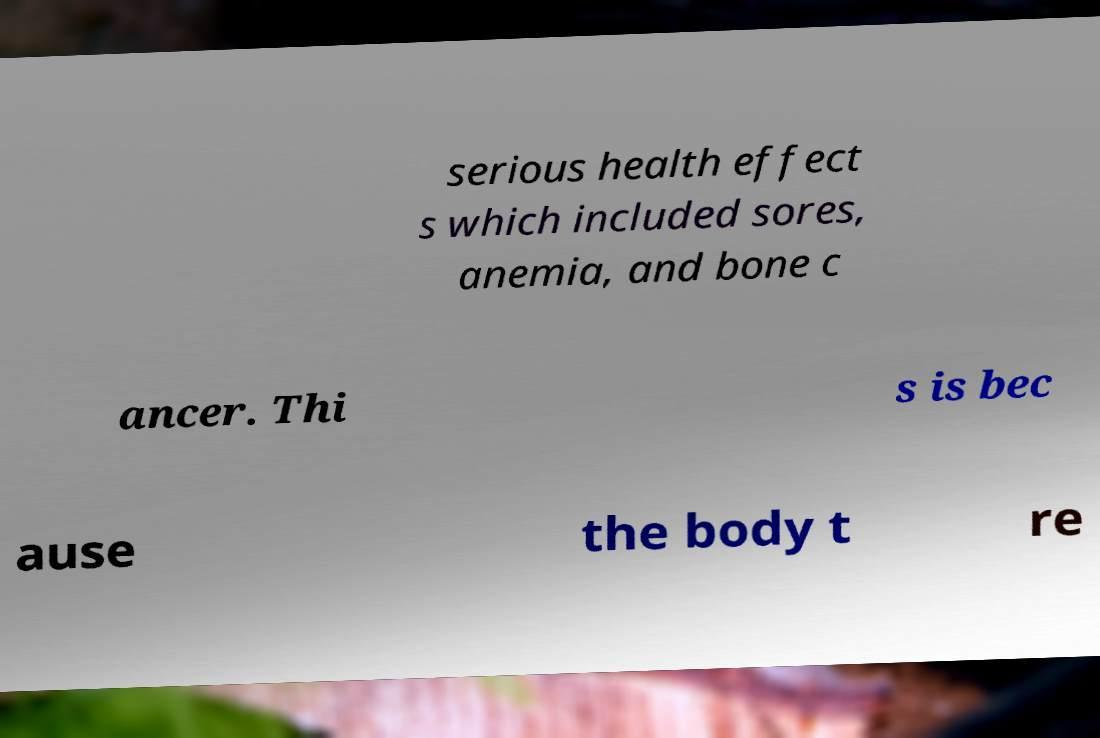Could you assist in decoding the text presented in this image and type it out clearly? serious health effect s which included sores, anemia, and bone c ancer. Thi s is bec ause the body t re 